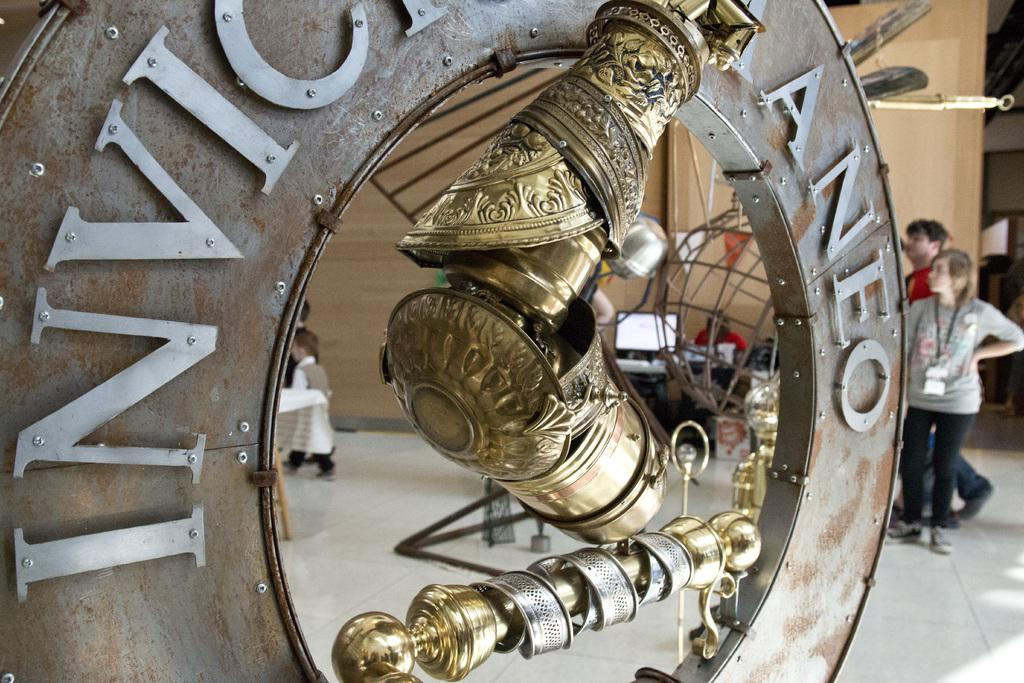What type of objects can be seen in the image? There are metal objects in the image. Can you describe one of the metal objects? There is a metal ring with writing on it. What can be seen in the background of the image? There is a wooden wall, people, tables, a monitor, flags, and a board in the background. How many bears are visible on the dock in the image? There is no dock or bears present in the image. What type of ship can be seen sailing in the background? There is no ship visible in the image. 